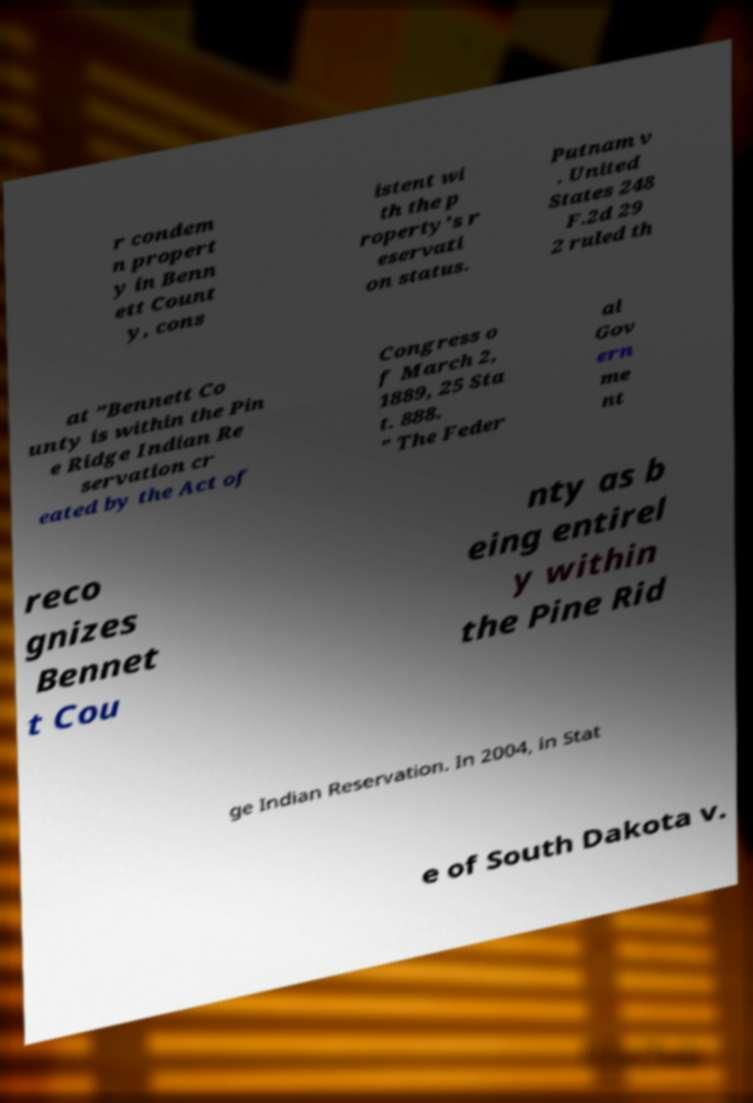Can you read and provide the text displayed in the image?This photo seems to have some interesting text. Can you extract and type it out for me? r condem n propert y in Benn ett Count y, cons istent wi th the p roperty's r eservati on status. Putnam v . United States 248 F.2d 29 2 ruled th at "Bennett Co unty is within the Pin e Ridge Indian Re servation cr eated by the Act of Congress o f March 2, 1889, 25 Sta t. 888. " The Feder al Gov ern me nt reco gnizes Bennet t Cou nty as b eing entirel y within the Pine Rid ge Indian Reservation. In 2004, in Stat e of South Dakota v. 